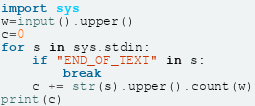<code> <loc_0><loc_0><loc_500><loc_500><_Python_>import sys
w=input().upper()
c=0
for s in sys.stdin:
    if "END_OF_TEXT" in s:
        break
    c += str(s).upper().count(w)
print(c)</code> 